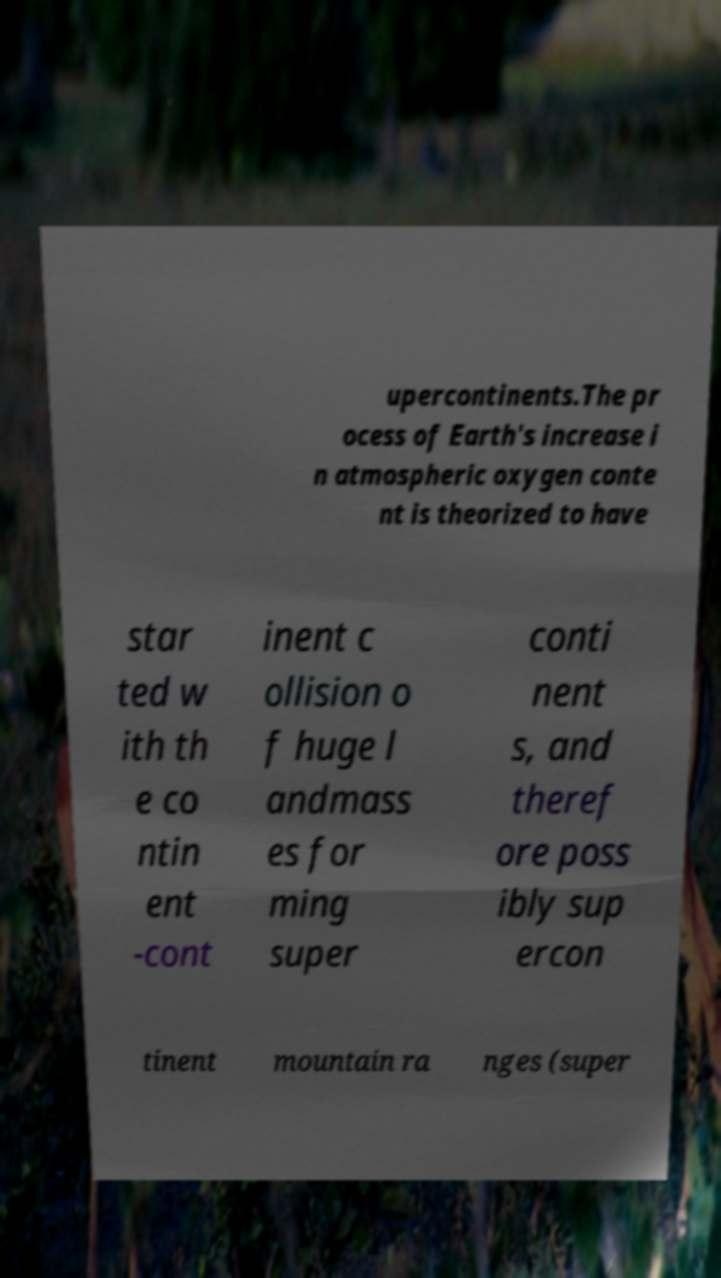Could you extract and type out the text from this image? upercontinents.The pr ocess of Earth's increase i n atmospheric oxygen conte nt is theorized to have star ted w ith th e co ntin ent -cont inent c ollision o f huge l andmass es for ming super conti nent s, and theref ore poss ibly sup ercon tinent mountain ra nges (super 